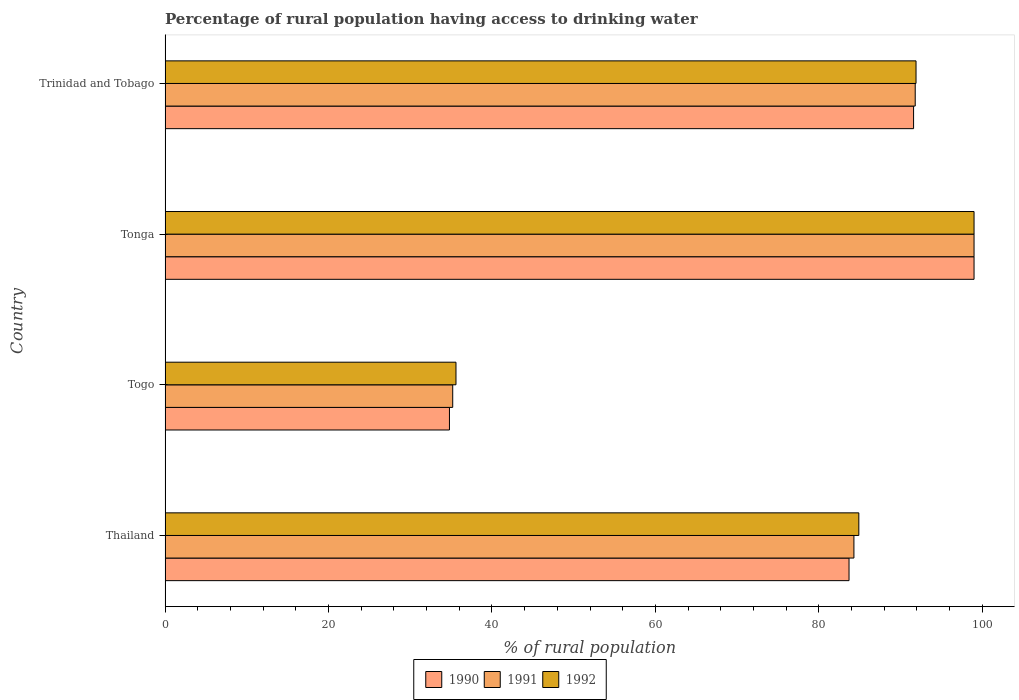How many different coloured bars are there?
Provide a short and direct response. 3. How many groups of bars are there?
Offer a terse response. 4. Are the number of bars per tick equal to the number of legend labels?
Keep it short and to the point. Yes. How many bars are there on the 2nd tick from the top?
Keep it short and to the point. 3. How many bars are there on the 4th tick from the bottom?
Keep it short and to the point. 3. What is the label of the 4th group of bars from the top?
Your answer should be compact. Thailand. In how many cases, is the number of bars for a given country not equal to the number of legend labels?
Offer a terse response. 0. What is the percentage of rural population having access to drinking water in 1991 in Tonga?
Keep it short and to the point. 99. Across all countries, what is the minimum percentage of rural population having access to drinking water in 1990?
Ensure brevity in your answer.  34.8. In which country was the percentage of rural population having access to drinking water in 1990 maximum?
Make the answer very short. Tonga. In which country was the percentage of rural population having access to drinking water in 1992 minimum?
Offer a terse response. Togo. What is the total percentage of rural population having access to drinking water in 1992 in the graph?
Your answer should be compact. 311.4. What is the difference between the percentage of rural population having access to drinking water in 1990 in Tonga and that in Trinidad and Tobago?
Ensure brevity in your answer.  7.4. What is the difference between the percentage of rural population having access to drinking water in 1990 in Tonga and the percentage of rural population having access to drinking water in 1992 in Thailand?
Ensure brevity in your answer.  14.1. What is the average percentage of rural population having access to drinking water in 1990 per country?
Provide a short and direct response. 77.28. What is the difference between the percentage of rural population having access to drinking water in 1991 and percentage of rural population having access to drinking water in 1992 in Togo?
Your answer should be compact. -0.4. In how many countries, is the percentage of rural population having access to drinking water in 1992 greater than 96 %?
Offer a terse response. 1. What is the ratio of the percentage of rural population having access to drinking water in 1990 in Thailand to that in Tonga?
Your response must be concise. 0.85. Is the percentage of rural population having access to drinking water in 1991 in Togo less than that in Trinidad and Tobago?
Provide a succinct answer. Yes. What is the difference between the highest and the second highest percentage of rural population having access to drinking water in 1992?
Provide a short and direct response. 7.1. What is the difference between the highest and the lowest percentage of rural population having access to drinking water in 1991?
Provide a short and direct response. 63.8. What does the 3rd bar from the top in Thailand represents?
Your answer should be compact. 1990. Is it the case that in every country, the sum of the percentage of rural population having access to drinking water in 1992 and percentage of rural population having access to drinking water in 1991 is greater than the percentage of rural population having access to drinking water in 1990?
Your answer should be compact. Yes. Are all the bars in the graph horizontal?
Make the answer very short. Yes. How many countries are there in the graph?
Ensure brevity in your answer.  4. What is the difference between two consecutive major ticks on the X-axis?
Make the answer very short. 20. Where does the legend appear in the graph?
Offer a terse response. Bottom center. How many legend labels are there?
Offer a very short reply. 3. How are the legend labels stacked?
Offer a very short reply. Horizontal. What is the title of the graph?
Your answer should be very brief. Percentage of rural population having access to drinking water. Does "2010" appear as one of the legend labels in the graph?
Ensure brevity in your answer.  No. What is the label or title of the X-axis?
Your answer should be compact. % of rural population. What is the % of rural population of 1990 in Thailand?
Offer a very short reply. 83.7. What is the % of rural population in 1991 in Thailand?
Provide a short and direct response. 84.3. What is the % of rural population in 1992 in Thailand?
Provide a short and direct response. 84.9. What is the % of rural population of 1990 in Togo?
Provide a succinct answer. 34.8. What is the % of rural population in 1991 in Togo?
Provide a short and direct response. 35.2. What is the % of rural population in 1992 in Togo?
Provide a short and direct response. 35.6. What is the % of rural population in 1992 in Tonga?
Your answer should be very brief. 99. What is the % of rural population of 1990 in Trinidad and Tobago?
Your response must be concise. 91.6. What is the % of rural population of 1991 in Trinidad and Tobago?
Give a very brief answer. 91.8. What is the % of rural population of 1992 in Trinidad and Tobago?
Provide a succinct answer. 91.9. Across all countries, what is the maximum % of rural population in 1990?
Your answer should be very brief. 99. Across all countries, what is the maximum % of rural population of 1991?
Provide a short and direct response. 99. Across all countries, what is the maximum % of rural population of 1992?
Your answer should be very brief. 99. Across all countries, what is the minimum % of rural population of 1990?
Provide a short and direct response. 34.8. Across all countries, what is the minimum % of rural population of 1991?
Keep it short and to the point. 35.2. Across all countries, what is the minimum % of rural population in 1992?
Provide a short and direct response. 35.6. What is the total % of rural population in 1990 in the graph?
Offer a terse response. 309.1. What is the total % of rural population of 1991 in the graph?
Keep it short and to the point. 310.3. What is the total % of rural population of 1992 in the graph?
Provide a short and direct response. 311.4. What is the difference between the % of rural population in 1990 in Thailand and that in Togo?
Provide a succinct answer. 48.9. What is the difference between the % of rural population of 1991 in Thailand and that in Togo?
Provide a short and direct response. 49.1. What is the difference between the % of rural population in 1992 in Thailand and that in Togo?
Make the answer very short. 49.3. What is the difference between the % of rural population in 1990 in Thailand and that in Tonga?
Provide a short and direct response. -15.3. What is the difference between the % of rural population of 1991 in Thailand and that in Tonga?
Provide a succinct answer. -14.7. What is the difference between the % of rural population in 1992 in Thailand and that in Tonga?
Provide a succinct answer. -14.1. What is the difference between the % of rural population in 1990 in Thailand and that in Trinidad and Tobago?
Ensure brevity in your answer.  -7.9. What is the difference between the % of rural population in 1991 in Thailand and that in Trinidad and Tobago?
Your answer should be very brief. -7.5. What is the difference between the % of rural population in 1992 in Thailand and that in Trinidad and Tobago?
Offer a very short reply. -7. What is the difference between the % of rural population of 1990 in Togo and that in Tonga?
Give a very brief answer. -64.2. What is the difference between the % of rural population of 1991 in Togo and that in Tonga?
Offer a terse response. -63.8. What is the difference between the % of rural population of 1992 in Togo and that in Tonga?
Your answer should be very brief. -63.4. What is the difference between the % of rural population of 1990 in Togo and that in Trinidad and Tobago?
Provide a succinct answer. -56.8. What is the difference between the % of rural population of 1991 in Togo and that in Trinidad and Tobago?
Your answer should be very brief. -56.6. What is the difference between the % of rural population of 1992 in Togo and that in Trinidad and Tobago?
Offer a very short reply. -56.3. What is the difference between the % of rural population in 1990 in Thailand and the % of rural population in 1991 in Togo?
Keep it short and to the point. 48.5. What is the difference between the % of rural population of 1990 in Thailand and the % of rural population of 1992 in Togo?
Your answer should be compact. 48.1. What is the difference between the % of rural population of 1991 in Thailand and the % of rural population of 1992 in Togo?
Your answer should be compact. 48.7. What is the difference between the % of rural population of 1990 in Thailand and the % of rural population of 1991 in Tonga?
Ensure brevity in your answer.  -15.3. What is the difference between the % of rural population in 1990 in Thailand and the % of rural population in 1992 in Tonga?
Your answer should be compact. -15.3. What is the difference between the % of rural population in 1991 in Thailand and the % of rural population in 1992 in Tonga?
Your answer should be very brief. -14.7. What is the difference between the % of rural population of 1990 in Thailand and the % of rural population of 1992 in Trinidad and Tobago?
Your response must be concise. -8.2. What is the difference between the % of rural population in 1991 in Thailand and the % of rural population in 1992 in Trinidad and Tobago?
Your answer should be compact. -7.6. What is the difference between the % of rural population of 1990 in Togo and the % of rural population of 1991 in Tonga?
Give a very brief answer. -64.2. What is the difference between the % of rural population of 1990 in Togo and the % of rural population of 1992 in Tonga?
Provide a short and direct response. -64.2. What is the difference between the % of rural population of 1991 in Togo and the % of rural population of 1992 in Tonga?
Your answer should be compact. -63.8. What is the difference between the % of rural population of 1990 in Togo and the % of rural population of 1991 in Trinidad and Tobago?
Make the answer very short. -57. What is the difference between the % of rural population in 1990 in Togo and the % of rural population in 1992 in Trinidad and Tobago?
Give a very brief answer. -57.1. What is the difference between the % of rural population of 1991 in Togo and the % of rural population of 1992 in Trinidad and Tobago?
Provide a succinct answer. -56.7. What is the difference between the % of rural population in 1991 in Tonga and the % of rural population in 1992 in Trinidad and Tobago?
Your response must be concise. 7.1. What is the average % of rural population of 1990 per country?
Your answer should be very brief. 77.28. What is the average % of rural population of 1991 per country?
Your response must be concise. 77.58. What is the average % of rural population of 1992 per country?
Your response must be concise. 77.85. What is the difference between the % of rural population in 1990 and % of rural population in 1992 in Togo?
Provide a succinct answer. -0.8. What is the difference between the % of rural population in 1990 and % of rural population in 1992 in Tonga?
Your response must be concise. 0. What is the difference between the % of rural population of 1991 and % of rural population of 1992 in Tonga?
Give a very brief answer. 0. What is the difference between the % of rural population in 1990 and % of rural population in 1991 in Trinidad and Tobago?
Offer a terse response. -0.2. What is the difference between the % of rural population of 1990 and % of rural population of 1992 in Trinidad and Tobago?
Provide a short and direct response. -0.3. What is the difference between the % of rural population in 1991 and % of rural population in 1992 in Trinidad and Tobago?
Ensure brevity in your answer.  -0.1. What is the ratio of the % of rural population in 1990 in Thailand to that in Togo?
Provide a succinct answer. 2.41. What is the ratio of the % of rural population in 1991 in Thailand to that in Togo?
Offer a very short reply. 2.39. What is the ratio of the % of rural population in 1992 in Thailand to that in Togo?
Give a very brief answer. 2.38. What is the ratio of the % of rural population in 1990 in Thailand to that in Tonga?
Provide a succinct answer. 0.85. What is the ratio of the % of rural population of 1991 in Thailand to that in Tonga?
Your answer should be very brief. 0.85. What is the ratio of the % of rural population in 1992 in Thailand to that in Tonga?
Keep it short and to the point. 0.86. What is the ratio of the % of rural population in 1990 in Thailand to that in Trinidad and Tobago?
Offer a very short reply. 0.91. What is the ratio of the % of rural population of 1991 in Thailand to that in Trinidad and Tobago?
Provide a succinct answer. 0.92. What is the ratio of the % of rural population in 1992 in Thailand to that in Trinidad and Tobago?
Offer a terse response. 0.92. What is the ratio of the % of rural population in 1990 in Togo to that in Tonga?
Make the answer very short. 0.35. What is the ratio of the % of rural population in 1991 in Togo to that in Tonga?
Your answer should be very brief. 0.36. What is the ratio of the % of rural population of 1992 in Togo to that in Tonga?
Provide a short and direct response. 0.36. What is the ratio of the % of rural population in 1990 in Togo to that in Trinidad and Tobago?
Keep it short and to the point. 0.38. What is the ratio of the % of rural population of 1991 in Togo to that in Trinidad and Tobago?
Provide a short and direct response. 0.38. What is the ratio of the % of rural population in 1992 in Togo to that in Trinidad and Tobago?
Your answer should be very brief. 0.39. What is the ratio of the % of rural population of 1990 in Tonga to that in Trinidad and Tobago?
Offer a terse response. 1.08. What is the ratio of the % of rural population of 1991 in Tonga to that in Trinidad and Tobago?
Give a very brief answer. 1.08. What is the ratio of the % of rural population of 1992 in Tonga to that in Trinidad and Tobago?
Your answer should be very brief. 1.08. What is the difference between the highest and the second highest % of rural population in 1992?
Provide a succinct answer. 7.1. What is the difference between the highest and the lowest % of rural population of 1990?
Offer a terse response. 64.2. What is the difference between the highest and the lowest % of rural population of 1991?
Your answer should be compact. 63.8. What is the difference between the highest and the lowest % of rural population of 1992?
Provide a succinct answer. 63.4. 